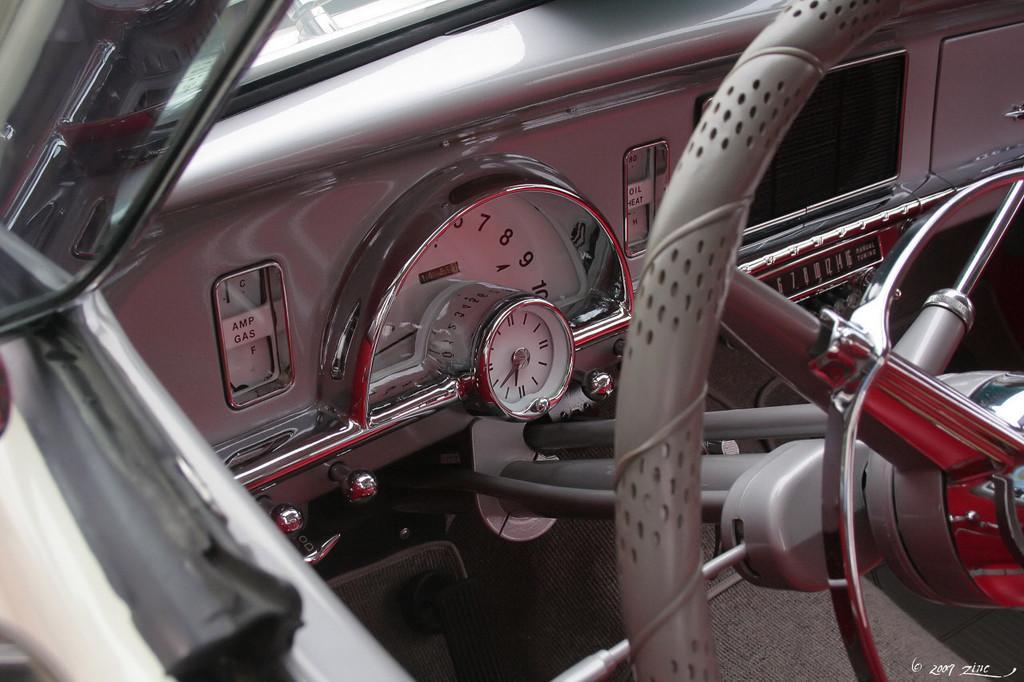In one or two sentences, can you explain what this image depicts? In this image, we can see an inside view of a vehicle. Here we can see steering, gauges and few objects. On the left side corner, there is a side mirror. 